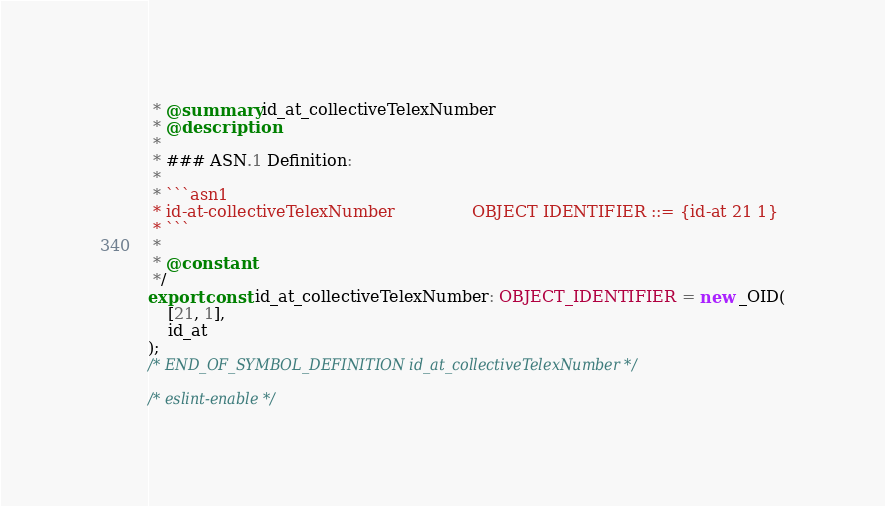<code> <loc_0><loc_0><loc_500><loc_500><_TypeScript_> * @summary id_at_collectiveTelexNumber
 * @description
 *
 * ### ASN.1 Definition:
 *
 * ```asn1
 * id-at-collectiveTelexNumber               OBJECT IDENTIFIER ::= {id-at 21 1}
 * ```
 *
 * @constant
 */
export const id_at_collectiveTelexNumber: OBJECT_IDENTIFIER = new _OID(
    [21, 1],
    id_at
);
/* END_OF_SYMBOL_DEFINITION id_at_collectiveTelexNumber */

/* eslint-enable */
</code> 